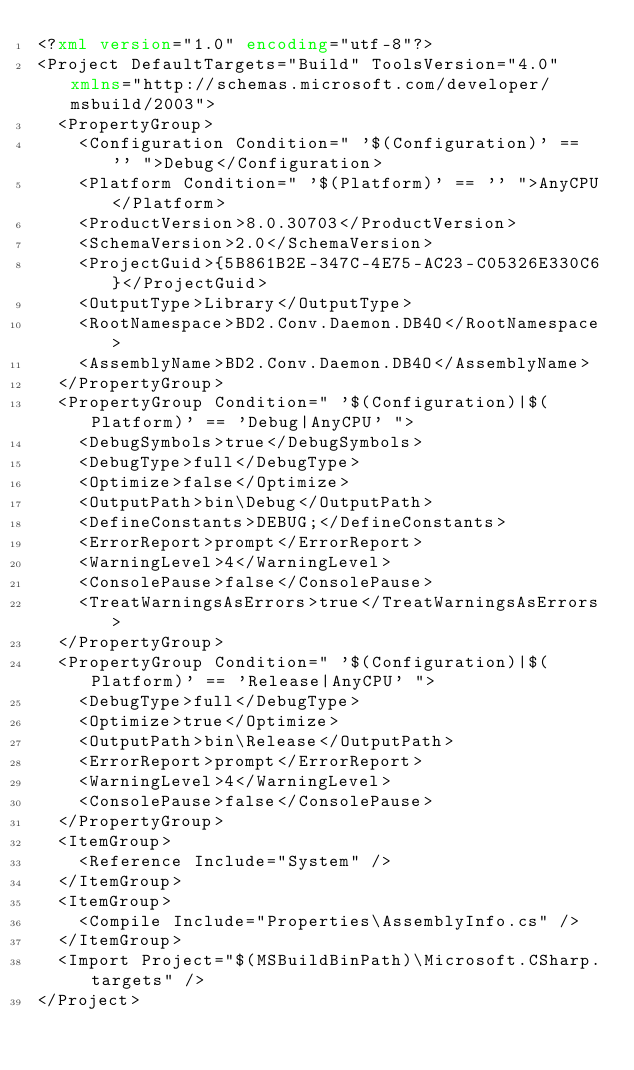Convert code to text. <code><loc_0><loc_0><loc_500><loc_500><_XML_><?xml version="1.0" encoding="utf-8"?>
<Project DefaultTargets="Build" ToolsVersion="4.0" xmlns="http://schemas.microsoft.com/developer/msbuild/2003">
  <PropertyGroup>
    <Configuration Condition=" '$(Configuration)' == '' ">Debug</Configuration>
    <Platform Condition=" '$(Platform)' == '' ">AnyCPU</Platform>
    <ProductVersion>8.0.30703</ProductVersion>
    <SchemaVersion>2.0</SchemaVersion>
    <ProjectGuid>{5B861B2E-347C-4E75-AC23-C05326E330C6}</ProjectGuid>
    <OutputType>Library</OutputType>
    <RootNamespace>BD2.Conv.Daemon.DB4O</RootNamespace>
    <AssemblyName>BD2.Conv.Daemon.DB4O</AssemblyName>
  </PropertyGroup>
  <PropertyGroup Condition=" '$(Configuration)|$(Platform)' == 'Debug|AnyCPU' ">
    <DebugSymbols>true</DebugSymbols>
    <DebugType>full</DebugType>
    <Optimize>false</Optimize>
    <OutputPath>bin\Debug</OutputPath>
    <DefineConstants>DEBUG;</DefineConstants>
    <ErrorReport>prompt</ErrorReport>
    <WarningLevel>4</WarningLevel>
    <ConsolePause>false</ConsolePause>
    <TreatWarningsAsErrors>true</TreatWarningsAsErrors>
  </PropertyGroup>
  <PropertyGroup Condition=" '$(Configuration)|$(Platform)' == 'Release|AnyCPU' ">
    <DebugType>full</DebugType>
    <Optimize>true</Optimize>
    <OutputPath>bin\Release</OutputPath>
    <ErrorReport>prompt</ErrorReport>
    <WarningLevel>4</WarningLevel>
    <ConsolePause>false</ConsolePause>
  </PropertyGroup>
  <ItemGroup>
    <Reference Include="System" />
  </ItemGroup>
  <ItemGroup>
    <Compile Include="Properties\AssemblyInfo.cs" />
  </ItemGroup>
  <Import Project="$(MSBuildBinPath)\Microsoft.CSharp.targets" />
</Project></code> 